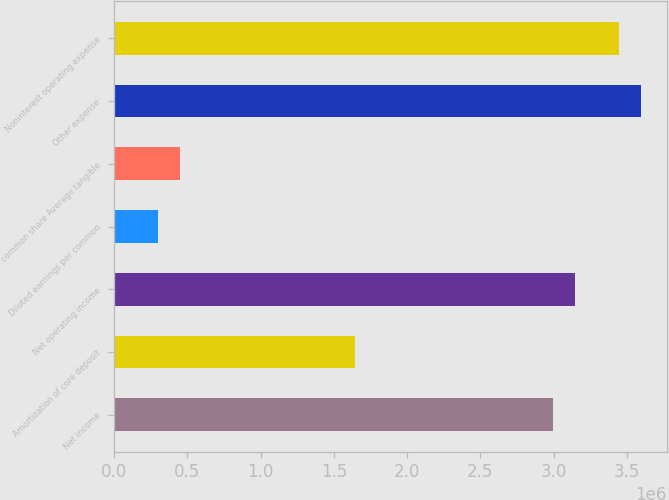Convert chart to OTSL. <chart><loc_0><loc_0><loc_500><loc_500><bar_chart><fcel>Net income<fcel>Amortization of core deposit<fcel>Net operating income<fcel>Diluted earnings per common<fcel>common share Average tangible<fcel>Other expense<fcel>Noninterest operating expense<nl><fcel>2.99496e+06<fcel>1.64723e+06<fcel>3.14471e+06<fcel>299496<fcel>449244<fcel>3.59395e+06<fcel>3.4442e+06<nl></chart> 